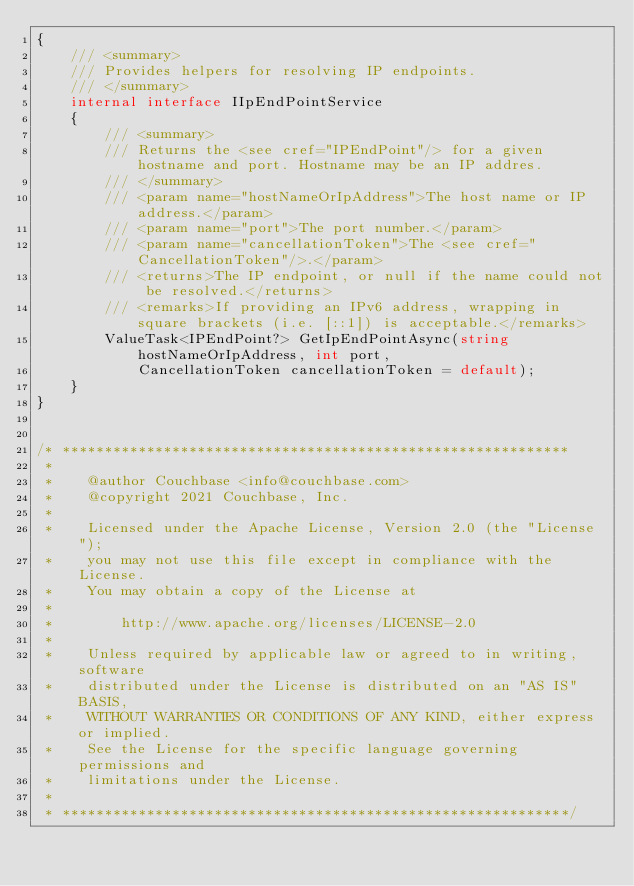Convert code to text. <code><loc_0><loc_0><loc_500><loc_500><_C#_>{
    /// <summary>
    /// Provides helpers for resolving IP endpoints.
    /// </summary>
    internal interface IIpEndPointService
    {
        /// <summary>
        /// Returns the <see cref="IPEndPoint"/> for a given hostname and port. Hostname may be an IP addres.
        /// </summary>
        /// <param name="hostNameOrIpAddress">The host name or IP address.</param>
        /// <param name="port">The port number.</param>
        /// <param name="cancellationToken">The <see cref="CancellationToken"/>.</param>
        /// <returns>The IP endpoint, or null if the name could not be resolved.</returns>
        /// <remarks>If providing an IPv6 address, wrapping in square brackets (i.e. [::1]) is acceptable.</remarks>
        ValueTask<IPEndPoint?> GetIpEndPointAsync(string hostNameOrIpAddress, int port,
            CancellationToken cancellationToken = default);
    }
}


/* ************************************************************
 *
 *    @author Couchbase <info@couchbase.com>
 *    @copyright 2021 Couchbase, Inc.
 *
 *    Licensed under the Apache License, Version 2.0 (the "License");
 *    you may not use this file except in compliance with the License.
 *    You may obtain a copy of the License at
 *
 *        http://www.apache.org/licenses/LICENSE-2.0
 *
 *    Unless required by applicable law or agreed to in writing, software
 *    distributed under the License is distributed on an "AS IS" BASIS,
 *    WITHOUT WARRANTIES OR CONDITIONS OF ANY KIND, either express or implied.
 *    See the License for the specific language governing permissions and
 *    limitations under the License.
 *
 * ************************************************************/
</code> 